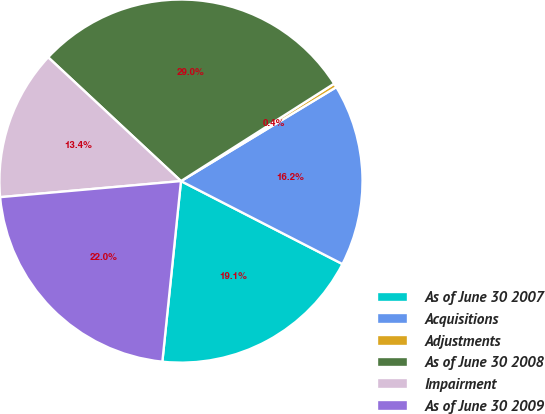Convert chart. <chart><loc_0><loc_0><loc_500><loc_500><pie_chart><fcel>As of June 30 2007<fcel>Acquisitions<fcel>Adjustments<fcel>As of June 30 2008<fcel>Impairment<fcel>As of June 30 2009<nl><fcel>19.08%<fcel>16.21%<fcel>0.36%<fcel>29.04%<fcel>13.35%<fcel>21.95%<nl></chart> 